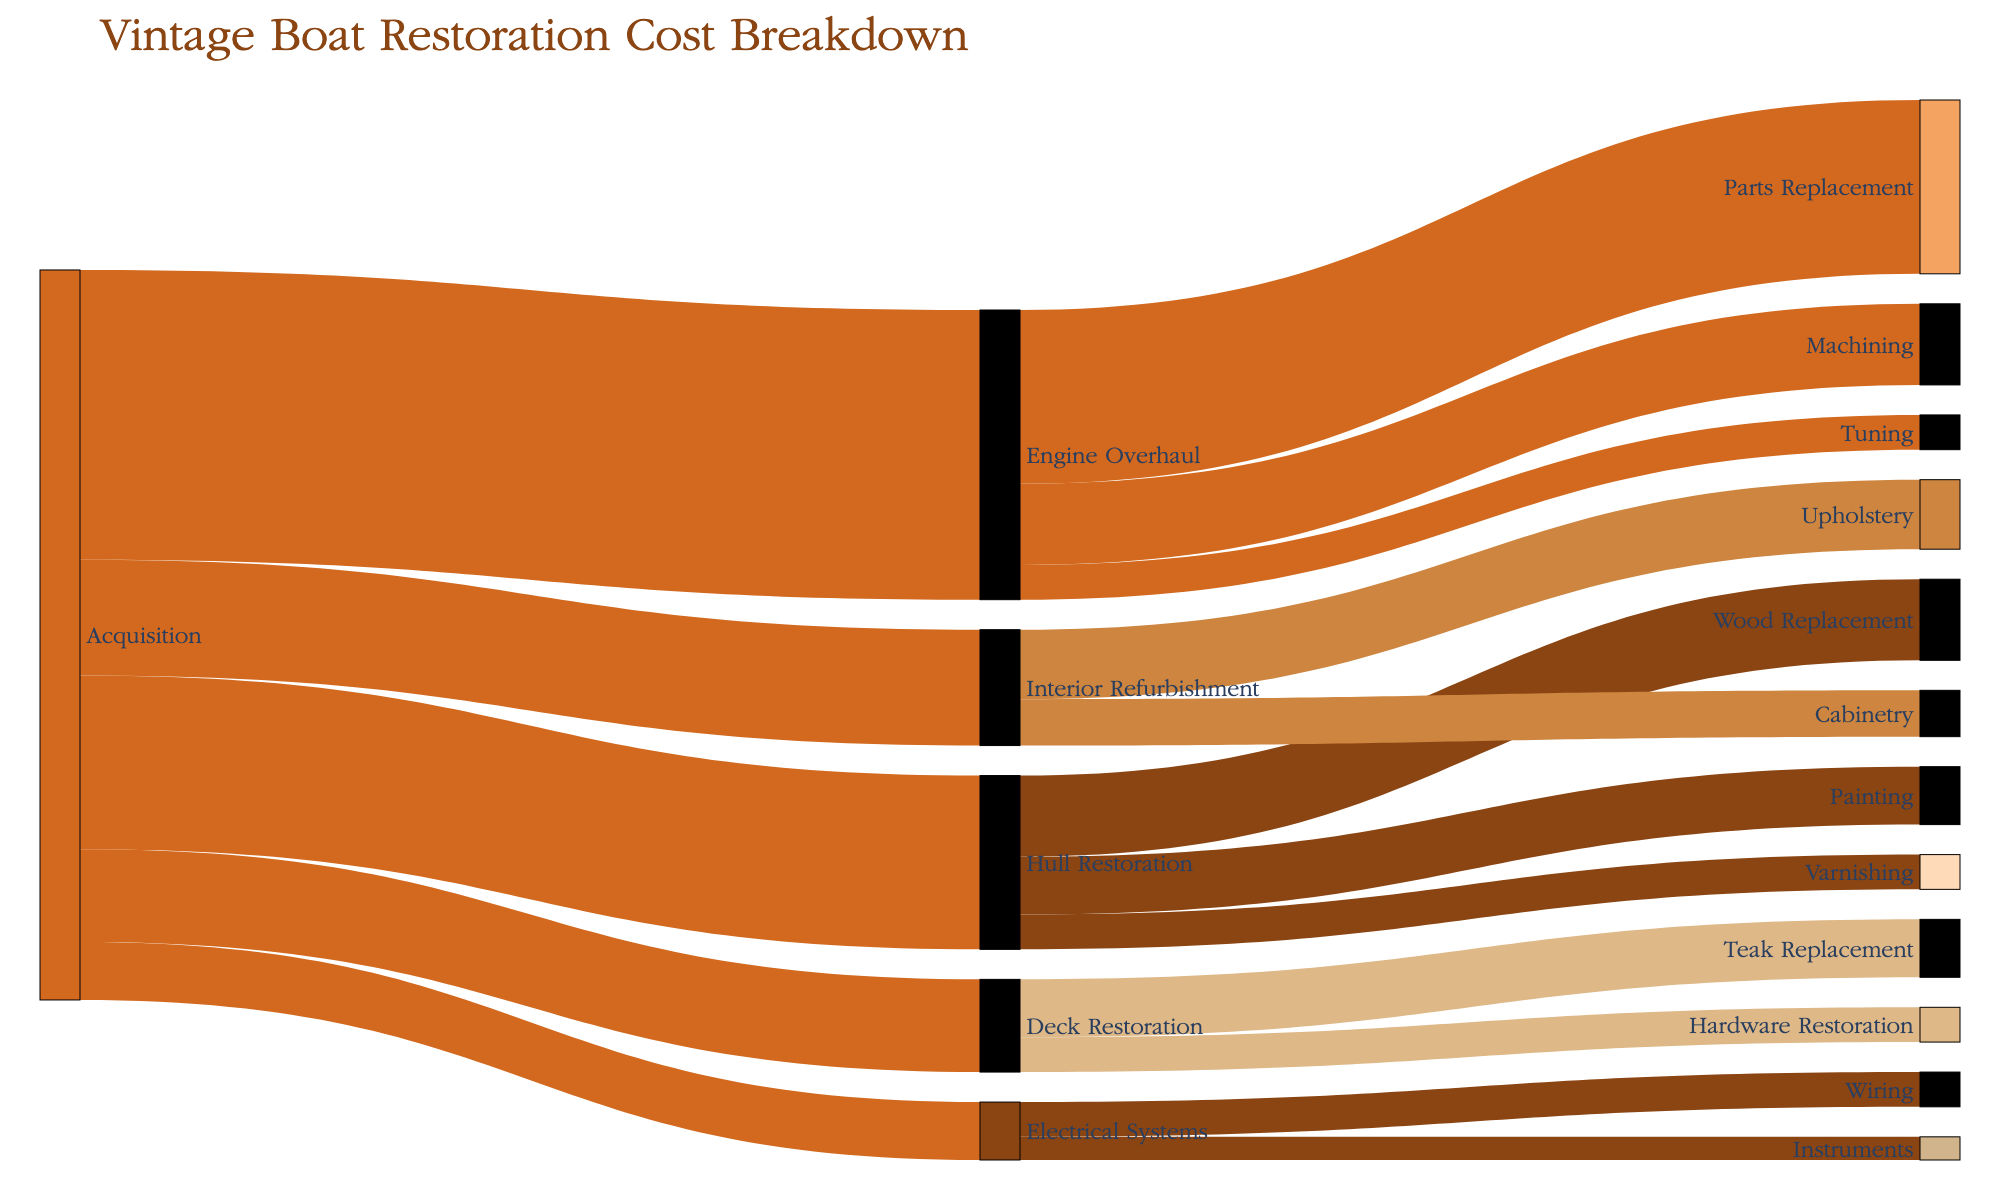What's the title of the Sankey diagram? The diagram has a title that is typically displayed at the top for easy identification. The title is "Vintage Boat Restoration Cost Breakdown."
Answer: Vintage Boat Restoration Cost Breakdown Which restoration category has the highest cost under the Acquisition phase? The branches from the Acquisition phase show varying costs. Engine Overhaul has the highest cost, which is 25000.
Answer: Engine Overhaul What is the total cost of Hull Restoration? Hull Restoration's costs include Wood Replacement, Painting, and Varnishing. Summing these up (7000 + 5000 + 3000) gives 15000.
Answer: 15000 How much more is spent on Engine Overhaul compared to Deck Restoration? The cost of Engine Overhaul is 25000, and Deck Restoration is 8000. The difference between them is 25000 - 8000 = 17000.
Answer: 17000 Which task under Engine Overhaul has the lowest cost? The tasks under Engine Overhaul are Parts Replacement (15000), Machining (7000), and Tuning (3000). Tuning has the lowest cost.
Answer: Tuning Compare the costs of Electrical Systems and Interior Refurbishment. Which one is higher and by how much? Electrical Systems total (Wiring 3000 + Instruments 2000) is 5000, while Interior Refurbishment (Upholstery 6000 + Cabinetry 4000) is 10000. Interior Refurbishment is higher by 10000 - 5000 = 5000.
Answer: Interior Refurbishment by 5000 What is the combined cost of the three components under Hull Restoration? The costs are Wood Replacement (7000), Painting (5000), and Varnishing (3000). Summing these gives 7000 + 5000 + 3000 = 15000.
Answer: 15000 What is the most expensive task listed in the diagram? By comparing all the listed costs, the most expensive task is Parts Replacement under Engine Overhaul at 15000.
Answer: Parts Replacement List all the tasks involved in Deck Restoration and their individual costs. The Sankey diagram shows that Deck Restoration involves Teak Replacement (5000) and Hardware Restoration (3000).
Answer: Teak Replacement 5000, Hardware Restoration 3000 